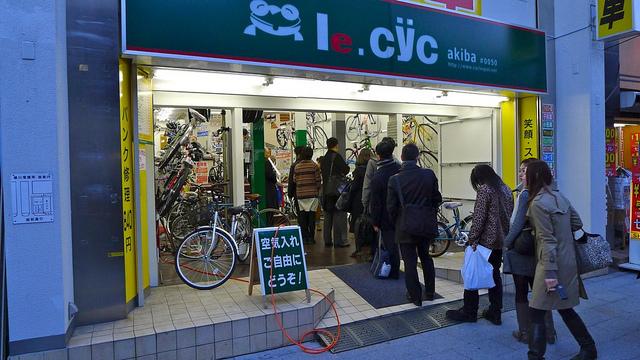Is the storefront sign in English?
Quick response, please. No. How many people are there?
Short answer required. 11. What is the name of this event?
Keep it brief. Lecyc. Does the store have a ramp?
Concise answer only. Yes. 